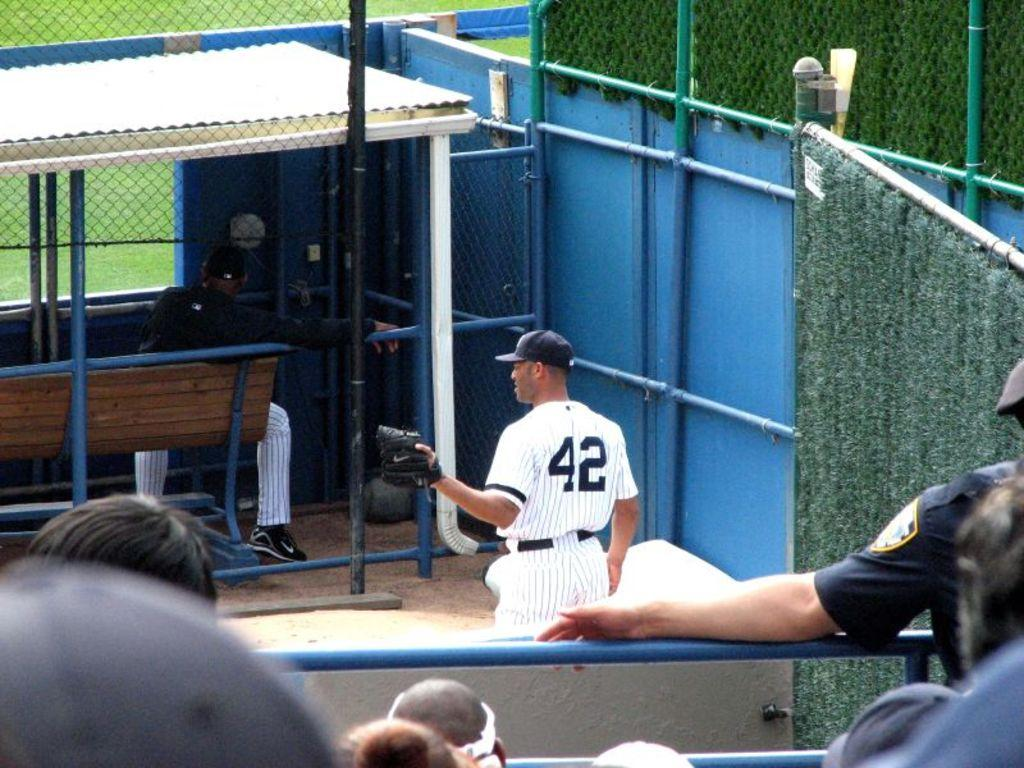<image>
Describe the image concisely. Player number 42 with his hand out to catch a ball. 